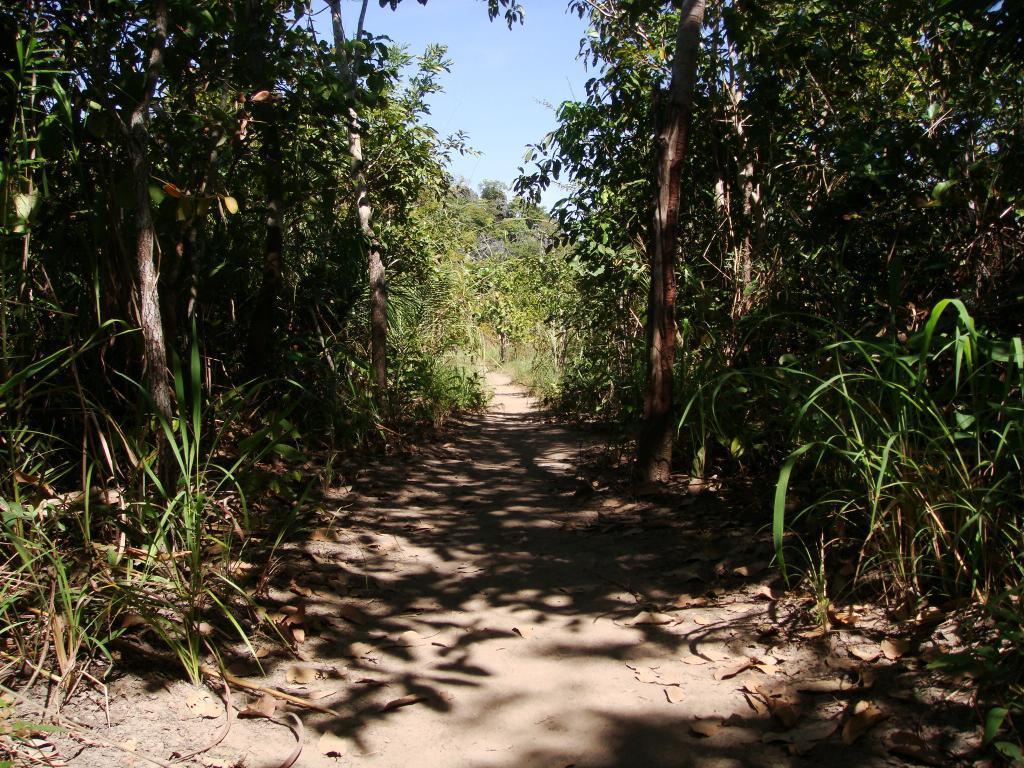In one or two sentences, can you explain what this image depicts? In the image we can see in between there is a footpath and on both sides there are lot of trees. 